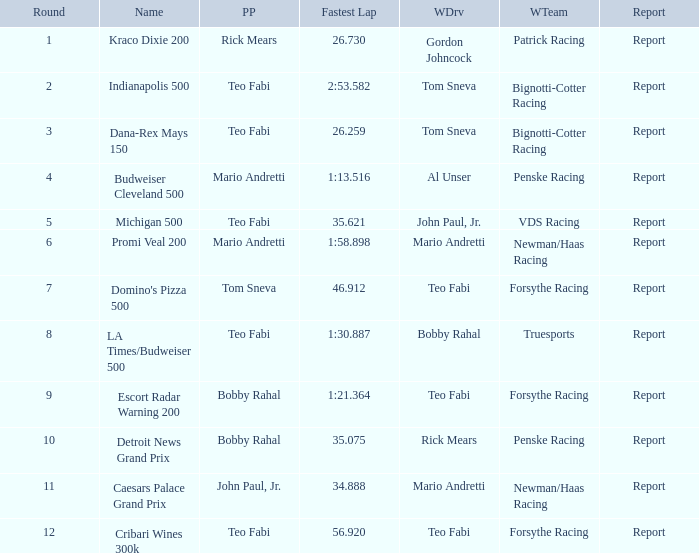Which teams won when Bobby Rahal was their winning driver? Truesports. 